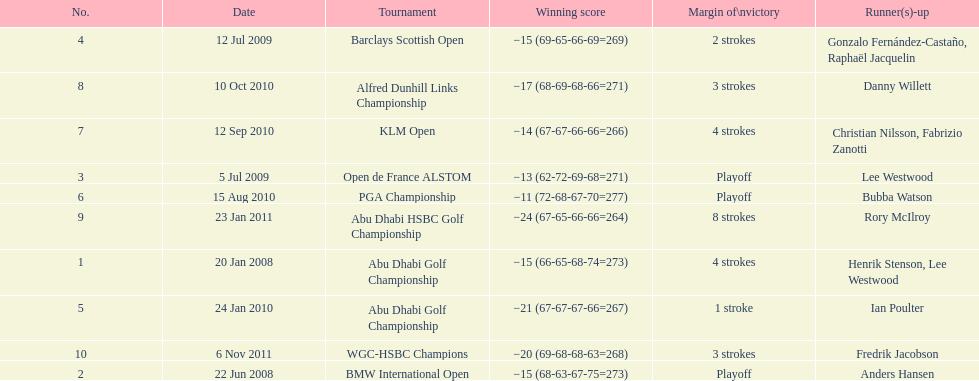How many winning scores were less than -14? 2. Write the full table. {'header': ['No.', 'Date', 'Tournament', 'Winning score', 'Margin of\\nvictory', 'Runner(s)-up'], 'rows': [['4', '12 Jul 2009', 'Barclays Scottish Open', '−15 (69-65-66-69=269)', '2 strokes', 'Gonzalo Fernández-Castaño, Raphaël Jacquelin'], ['8', '10 Oct 2010', 'Alfred Dunhill Links Championship', '−17 (68-69-68-66=271)', '3 strokes', 'Danny Willett'], ['7', '12 Sep 2010', 'KLM Open', '−14 (67-67-66-66=266)', '4 strokes', 'Christian Nilsson, Fabrizio Zanotti'], ['3', '5 Jul 2009', 'Open de France ALSTOM', '−13 (62-72-69-68=271)', 'Playoff', 'Lee Westwood'], ['6', '15 Aug 2010', 'PGA Championship', '−11 (72-68-67-70=277)', 'Playoff', 'Bubba Watson'], ['9', '23 Jan 2011', 'Abu Dhabi HSBC Golf Championship', '−24 (67-65-66-66=264)', '8 strokes', 'Rory McIlroy'], ['1', '20 Jan 2008', 'Abu Dhabi Golf Championship', '−15 (66-65-68-74=273)', '4 strokes', 'Henrik Stenson, Lee Westwood'], ['5', '24 Jan 2010', 'Abu Dhabi Golf Championship', '−21 (67-67-67-66=267)', '1 stroke', 'Ian Poulter'], ['10', '6 Nov 2011', 'WGC-HSBC Champions', '−20 (69-68-68-63=268)', '3 strokes', 'Fredrik Jacobson'], ['2', '22 Jun 2008', 'BMW International Open', '−15 (68-63-67-75=273)', 'Playoff', 'Anders Hansen']]} 